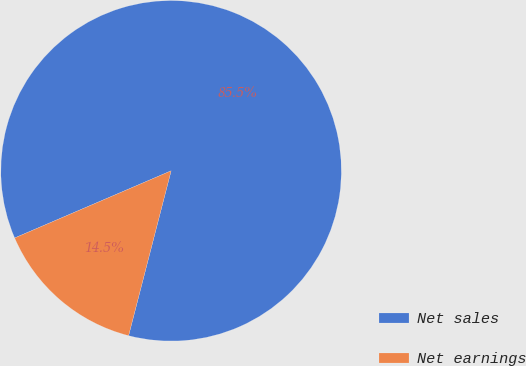Convert chart to OTSL. <chart><loc_0><loc_0><loc_500><loc_500><pie_chart><fcel>Net sales<fcel>Net earnings<nl><fcel>85.47%<fcel>14.53%<nl></chart> 